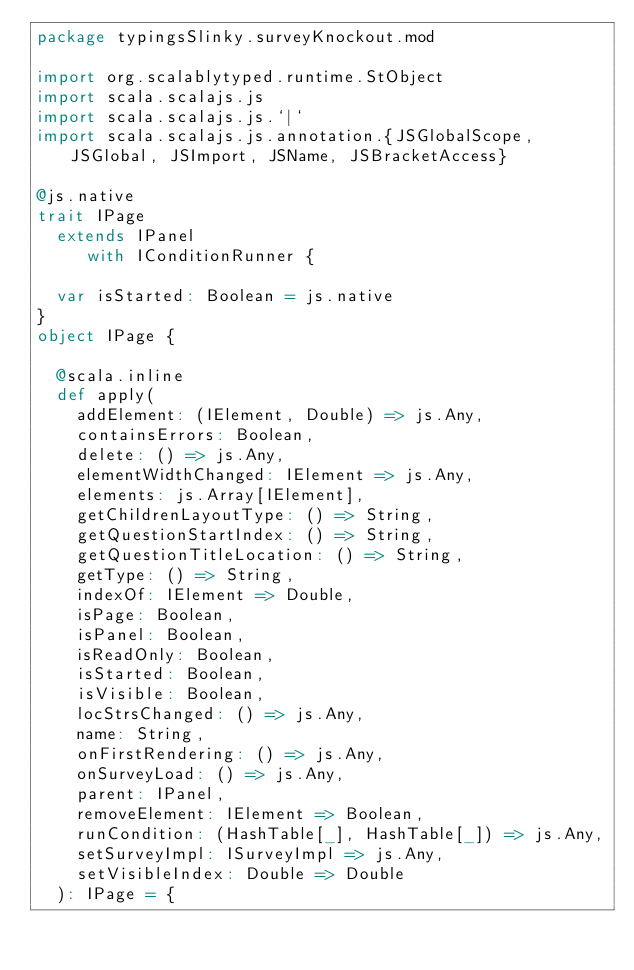<code> <loc_0><loc_0><loc_500><loc_500><_Scala_>package typingsSlinky.surveyKnockout.mod

import org.scalablytyped.runtime.StObject
import scala.scalajs.js
import scala.scalajs.js.`|`
import scala.scalajs.js.annotation.{JSGlobalScope, JSGlobal, JSImport, JSName, JSBracketAccess}

@js.native
trait IPage
  extends IPanel
     with IConditionRunner {
  
  var isStarted: Boolean = js.native
}
object IPage {
  
  @scala.inline
  def apply(
    addElement: (IElement, Double) => js.Any,
    containsErrors: Boolean,
    delete: () => js.Any,
    elementWidthChanged: IElement => js.Any,
    elements: js.Array[IElement],
    getChildrenLayoutType: () => String,
    getQuestionStartIndex: () => String,
    getQuestionTitleLocation: () => String,
    getType: () => String,
    indexOf: IElement => Double,
    isPage: Boolean,
    isPanel: Boolean,
    isReadOnly: Boolean,
    isStarted: Boolean,
    isVisible: Boolean,
    locStrsChanged: () => js.Any,
    name: String,
    onFirstRendering: () => js.Any,
    onSurveyLoad: () => js.Any,
    parent: IPanel,
    removeElement: IElement => Boolean,
    runCondition: (HashTable[_], HashTable[_]) => js.Any,
    setSurveyImpl: ISurveyImpl => js.Any,
    setVisibleIndex: Double => Double
  ): IPage = {</code> 